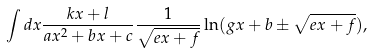<formula> <loc_0><loc_0><loc_500><loc_500>\int d x \frac { k x + l } { a x ^ { 2 } + b x + c } \frac { 1 } { \sqrt { e x + f } } \ln ( g x + b \pm \sqrt { e x + f } ) ,</formula> 